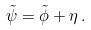Convert formula to latex. <formula><loc_0><loc_0><loc_500><loc_500>\tilde { \psi } = \tilde { \phi } + \eta \, .</formula> 